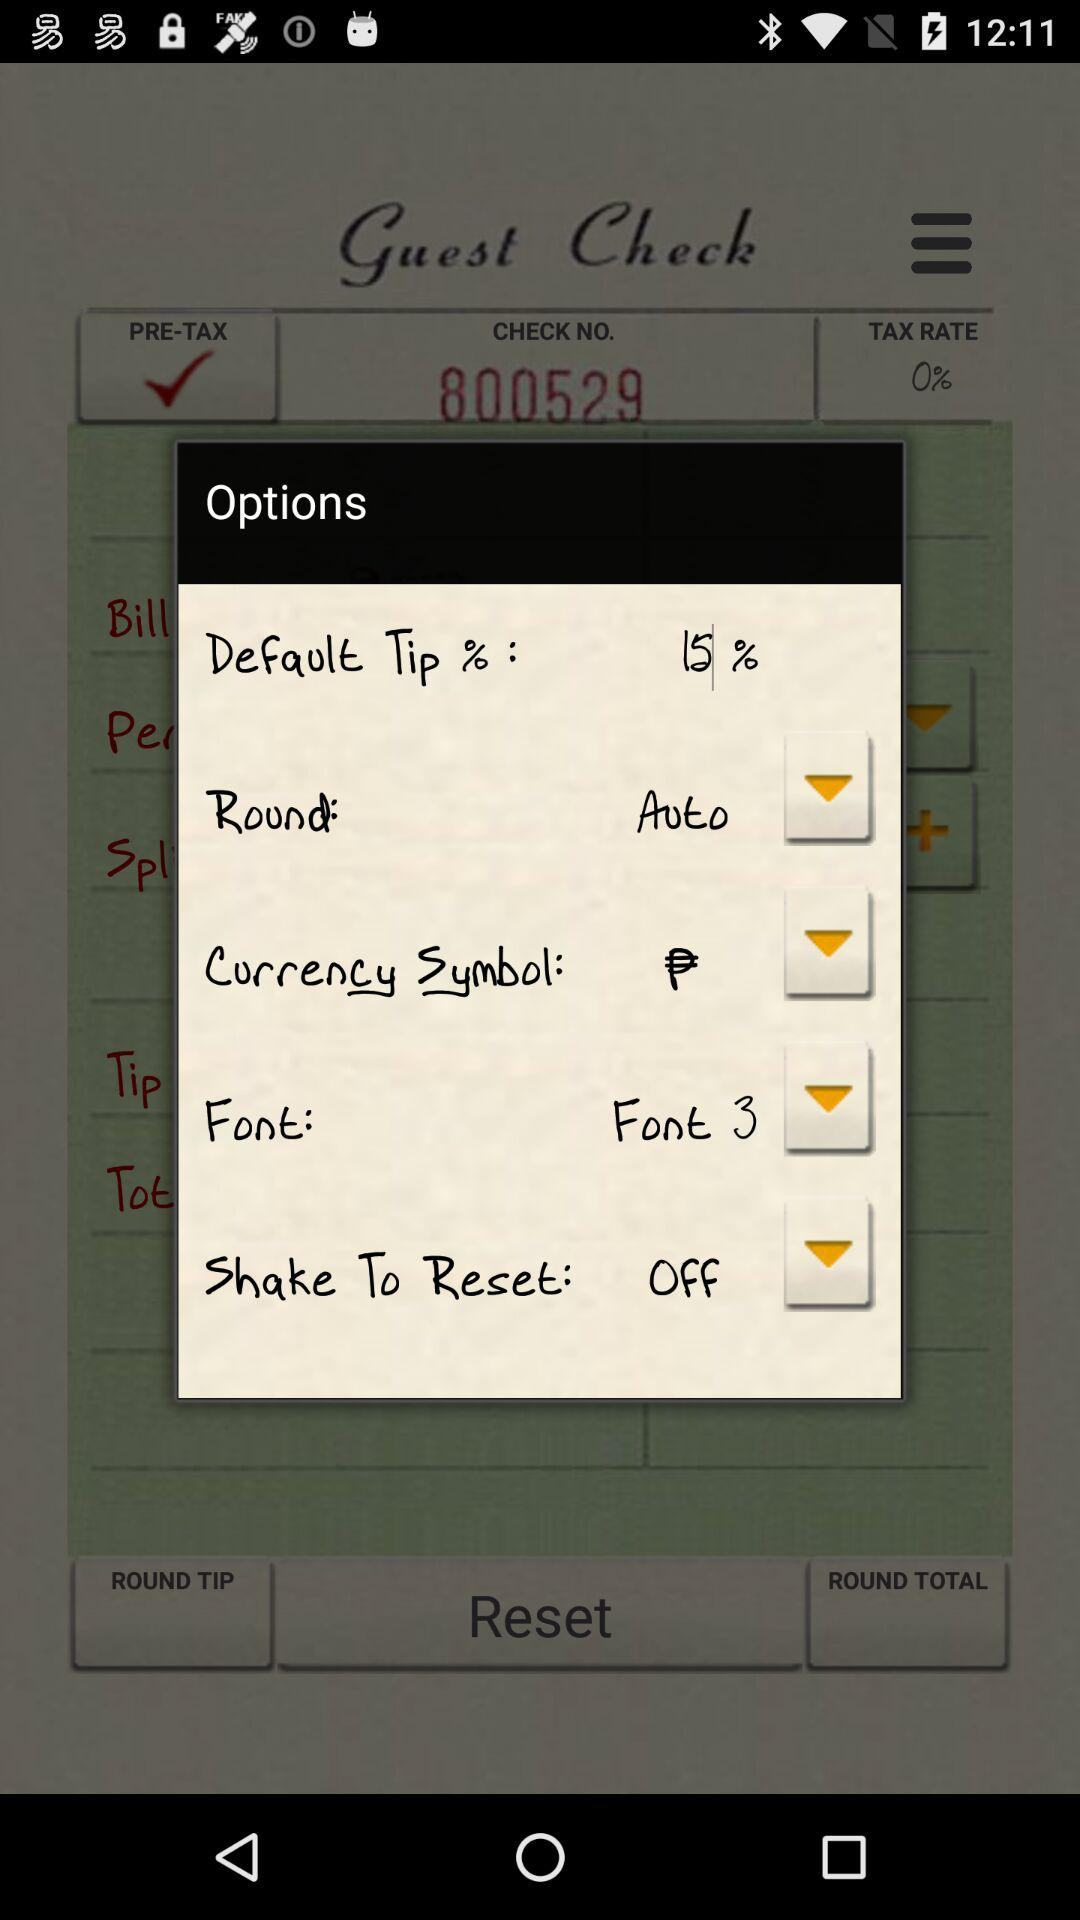What is the provided check number? The check number is 800529. 